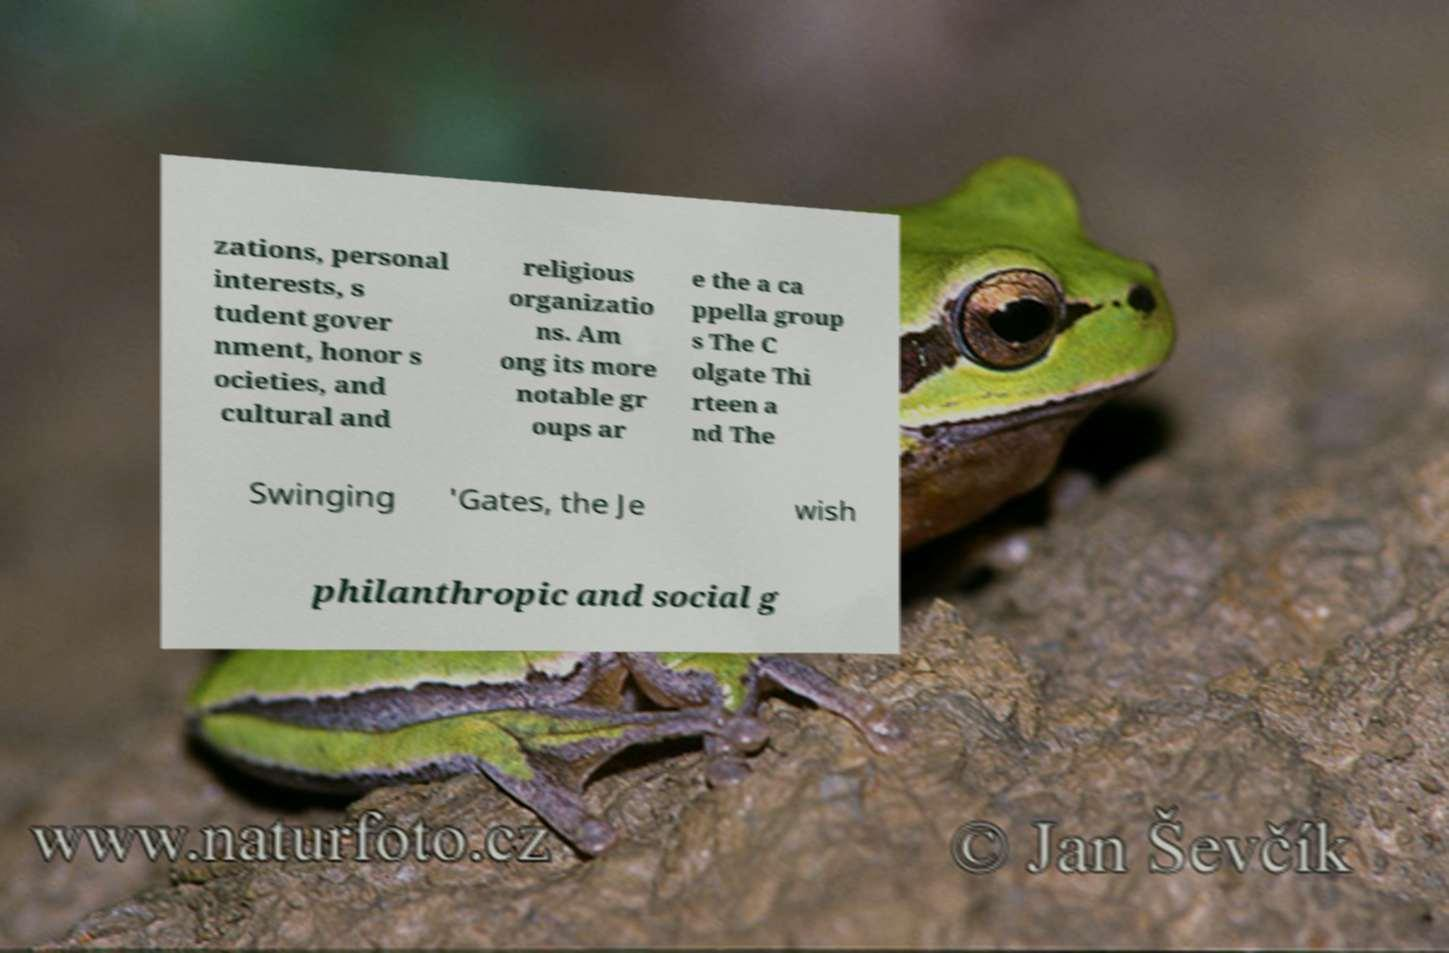Please identify and transcribe the text found in this image. zations, personal interests, s tudent gover nment, honor s ocieties, and cultural and religious organizatio ns. Am ong its more notable gr oups ar e the a ca ppella group s The C olgate Thi rteen a nd The Swinging 'Gates, the Je wish philanthropic and social g 